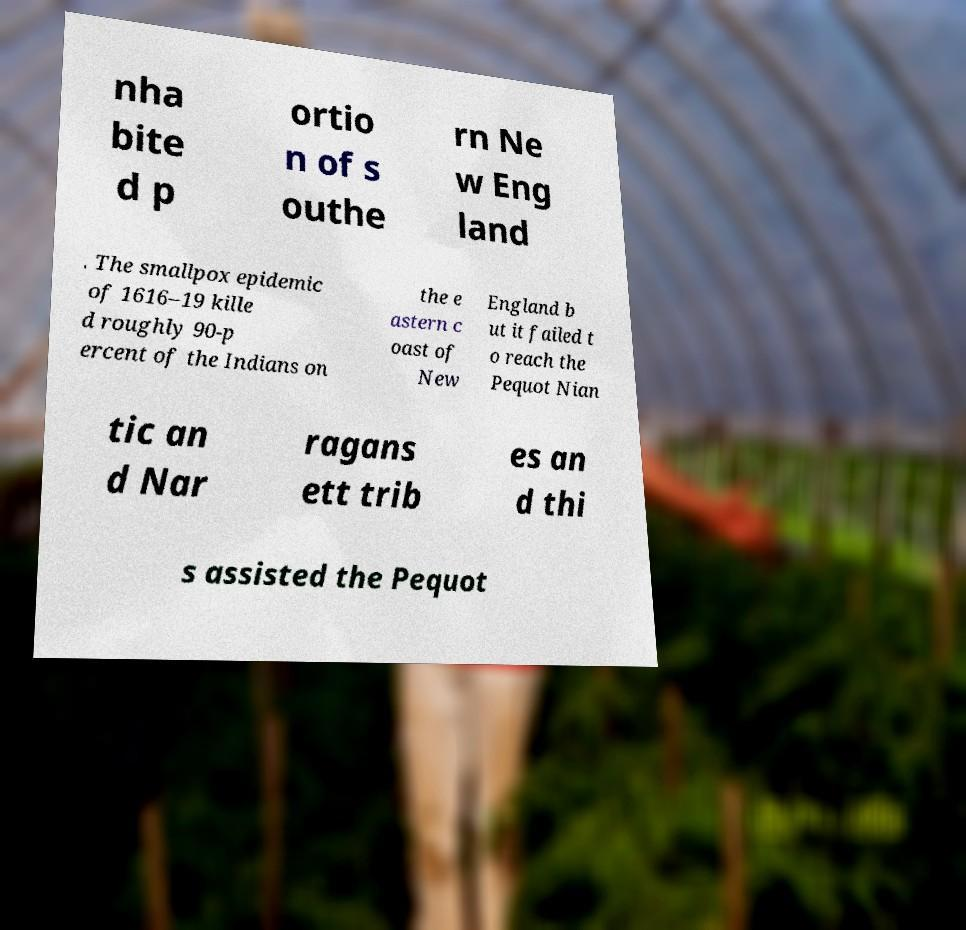For documentation purposes, I need the text within this image transcribed. Could you provide that? nha bite d p ortio n of s outhe rn Ne w Eng land . The smallpox epidemic of 1616–19 kille d roughly 90-p ercent of the Indians on the e astern c oast of New England b ut it failed t o reach the Pequot Nian tic an d Nar ragans ett trib es an d thi s assisted the Pequot 